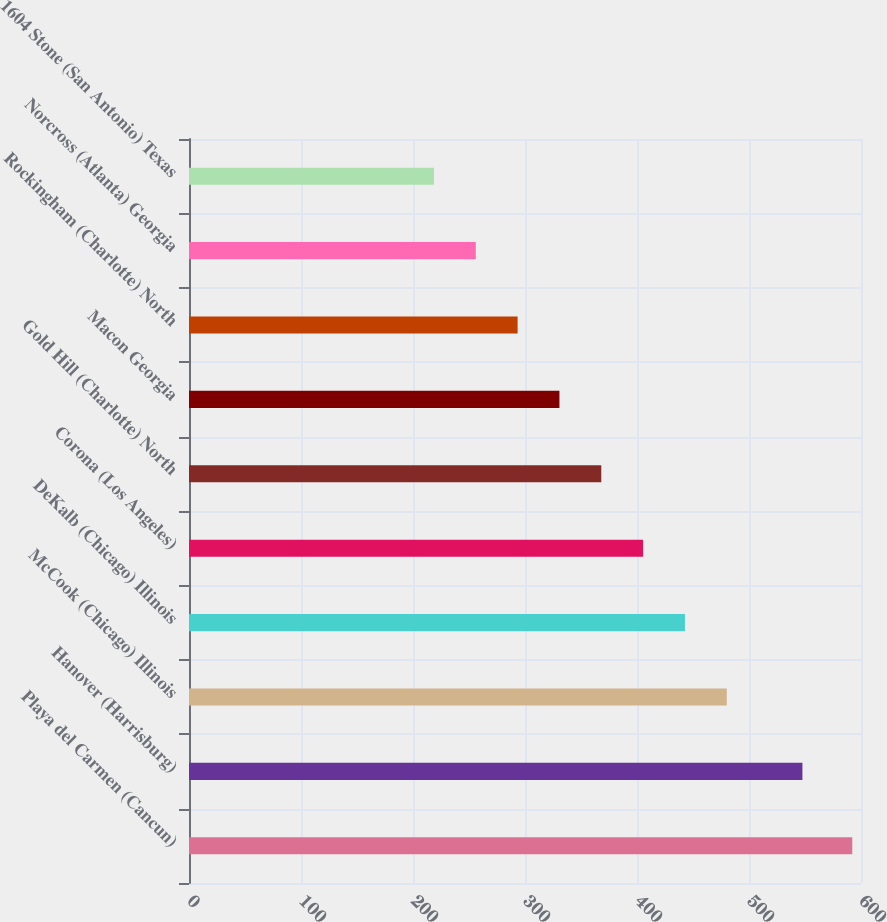<chart> <loc_0><loc_0><loc_500><loc_500><bar_chart><fcel>Playa del Carmen (Cancun)<fcel>Hanover (Harrisburg)<fcel>McCook (Chicago) Illinois<fcel>DeKalb (Chicago) Illinois<fcel>Corona (Los Angeles)<fcel>Gold Hill (Charlotte) North<fcel>Macon Georgia<fcel>Rockingham (Charlotte) North<fcel>Norcross (Atlanta) Georgia<fcel>1604 Stone (San Antonio) Texas<nl><fcel>592.2<fcel>547.7<fcel>480.15<fcel>442.8<fcel>405.45<fcel>368.1<fcel>330.75<fcel>293.4<fcel>256.05<fcel>218.7<nl></chart> 